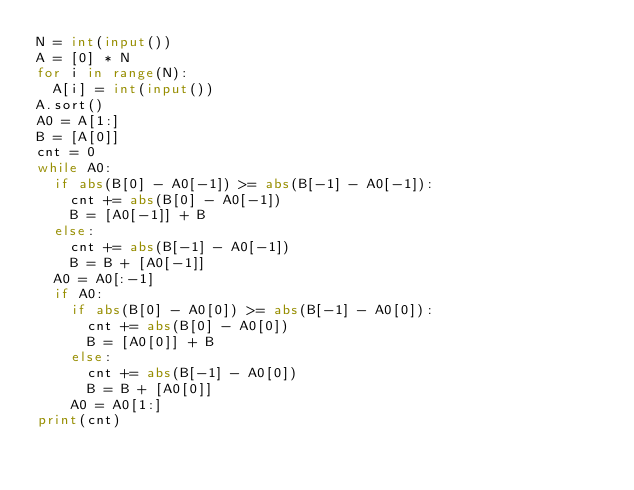Convert code to text. <code><loc_0><loc_0><loc_500><loc_500><_Python_>N = int(input())
A = [0] * N
for i in range(N):
  A[i] = int(input())
A.sort()
A0 = A[1:]
B = [A[0]]
cnt = 0
while A0:
  if abs(B[0] - A0[-1]) >= abs(B[-1] - A0[-1]):
    cnt += abs(B[0] - A0[-1])
    B = [A0[-1]] + B
  else:
    cnt += abs(B[-1] - A0[-1])
    B = B + [A0[-1]]
  A0 = A0[:-1]
  if A0:
    if abs(B[0] - A0[0]) >= abs(B[-1] - A0[0]):
      cnt += abs(B[0] - A0[0])
      B = [A0[0]] + B
    else:
      cnt += abs(B[-1] - A0[0])
      B = B + [A0[0]]
    A0 = A0[1:]
print(cnt)</code> 